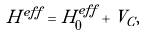<formula> <loc_0><loc_0><loc_500><loc_500>H ^ { e f f } = H ^ { e f f } _ { 0 } + V _ { C } ,</formula> 